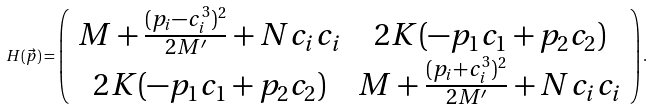Convert formula to latex. <formula><loc_0><loc_0><loc_500><loc_500>H ( \vec { p } ) = \left ( \begin{array} { c c } M + \frac { ( p _ { i } - c _ { i } ^ { 3 } ) ^ { 2 } } { 2 M ^ { \prime } } + N c _ { i } c _ { i } & 2 K ( - p _ { 1 } c _ { 1 } + p _ { 2 } c _ { 2 } ) \\ 2 K ( - p _ { 1 } c _ { 1 } + p _ { 2 } c _ { 2 } ) & M + \frac { ( p _ { i } + c _ { i } ^ { 3 } ) ^ { 2 } } { 2 M ^ { \prime } } + N c _ { i } c _ { i } \end{array} \right ) .</formula> 